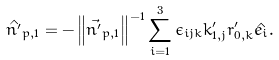Convert formula to latex. <formula><loc_0><loc_0><loc_500><loc_500>\hat { n ^ { \prime } } _ { p , 1 } & = - \left \| \vec { n ^ { \prime } } _ { p , 1 } \right \| ^ { - 1 } \sum _ { i = 1 } ^ { 3 } \epsilon _ { i j k } k ^ { \prime } _ { 1 , j } r ^ { \prime } _ { 0 , k } \hat { e _ { i } } .</formula> 